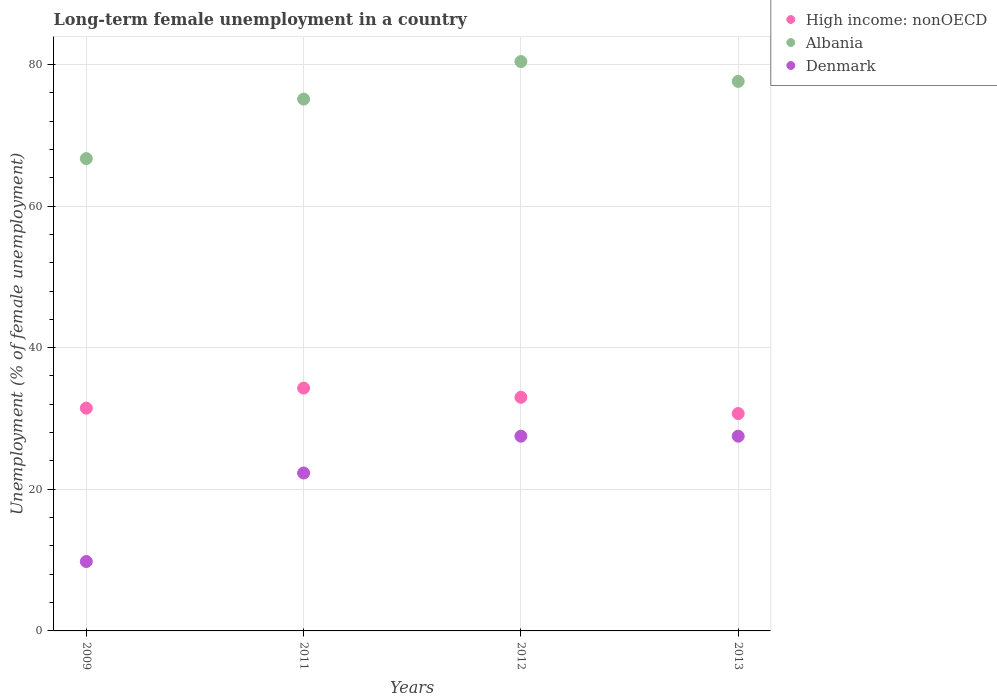What is the percentage of long-term unemployed female population in Albania in 2009?
Provide a short and direct response. 66.7. Across all years, what is the maximum percentage of long-term unemployed female population in High income: nonOECD?
Make the answer very short. 34.29. Across all years, what is the minimum percentage of long-term unemployed female population in Denmark?
Your answer should be very brief. 9.8. In which year was the percentage of long-term unemployed female population in High income: nonOECD minimum?
Your answer should be very brief. 2013. What is the total percentage of long-term unemployed female population in Denmark in the graph?
Keep it short and to the point. 87.1. What is the difference between the percentage of long-term unemployed female population in High income: nonOECD in 2011 and that in 2012?
Ensure brevity in your answer.  1.3. What is the difference between the percentage of long-term unemployed female population in High income: nonOECD in 2013 and the percentage of long-term unemployed female population in Denmark in 2009?
Your response must be concise. 20.9. What is the average percentage of long-term unemployed female population in Denmark per year?
Make the answer very short. 21.77. In the year 2011, what is the difference between the percentage of long-term unemployed female population in High income: nonOECD and percentage of long-term unemployed female population in Denmark?
Offer a very short reply. 11.99. In how many years, is the percentage of long-term unemployed female population in High income: nonOECD greater than 64 %?
Keep it short and to the point. 0. What is the ratio of the percentage of long-term unemployed female population in High income: nonOECD in 2009 to that in 2011?
Make the answer very short. 0.92. What is the difference between the highest and the lowest percentage of long-term unemployed female population in Denmark?
Your answer should be compact. 17.7. In how many years, is the percentage of long-term unemployed female population in Albania greater than the average percentage of long-term unemployed female population in Albania taken over all years?
Make the answer very short. 3. Is the sum of the percentage of long-term unemployed female population in Denmark in 2011 and 2013 greater than the maximum percentage of long-term unemployed female population in High income: nonOECD across all years?
Offer a very short reply. Yes. Does the percentage of long-term unemployed female population in Albania monotonically increase over the years?
Offer a terse response. No. Is the percentage of long-term unemployed female population in Denmark strictly greater than the percentage of long-term unemployed female population in Albania over the years?
Offer a terse response. No. How many years are there in the graph?
Your answer should be very brief. 4. Are the values on the major ticks of Y-axis written in scientific E-notation?
Give a very brief answer. No. Does the graph contain any zero values?
Provide a short and direct response. No. How many legend labels are there?
Offer a terse response. 3. How are the legend labels stacked?
Your answer should be compact. Vertical. What is the title of the graph?
Offer a terse response. Long-term female unemployment in a country. Does "St. Vincent and the Grenadines" appear as one of the legend labels in the graph?
Ensure brevity in your answer.  No. What is the label or title of the Y-axis?
Offer a very short reply. Unemployment (% of female unemployment). What is the Unemployment (% of female unemployment) of High income: nonOECD in 2009?
Ensure brevity in your answer.  31.45. What is the Unemployment (% of female unemployment) of Albania in 2009?
Provide a succinct answer. 66.7. What is the Unemployment (% of female unemployment) of Denmark in 2009?
Provide a short and direct response. 9.8. What is the Unemployment (% of female unemployment) in High income: nonOECD in 2011?
Offer a very short reply. 34.29. What is the Unemployment (% of female unemployment) in Albania in 2011?
Keep it short and to the point. 75.1. What is the Unemployment (% of female unemployment) of Denmark in 2011?
Your response must be concise. 22.3. What is the Unemployment (% of female unemployment) of High income: nonOECD in 2012?
Your response must be concise. 32.99. What is the Unemployment (% of female unemployment) in Albania in 2012?
Offer a very short reply. 80.4. What is the Unemployment (% of female unemployment) in High income: nonOECD in 2013?
Make the answer very short. 30.7. What is the Unemployment (% of female unemployment) in Albania in 2013?
Provide a succinct answer. 77.6. Across all years, what is the maximum Unemployment (% of female unemployment) in High income: nonOECD?
Make the answer very short. 34.29. Across all years, what is the maximum Unemployment (% of female unemployment) in Albania?
Keep it short and to the point. 80.4. Across all years, what is the maximum Unemployment (% of female unemployment) of Denmark?
Ensure brevity in your answer.  27.5. Across all years, what is the minimum Unemployment (% of female unemployment) of High income: nonOECD?
Ensure brevity in your answer.  30.7. Across all years, what is the minimum Unemployment (% of female unemployment) of Albania?
Provide a succinct answer. 66.7. Across all years, what is the minimum Unemployment (% of female unemployment) of Denmark?
Your answer should be compact. 9.8. What is the total Unemployment (% of female unemployment) of High income: nonOECD in the graph?
Provide a succinct answer. 129.43. What is the total Unemployment (% of female unemployment) of Albania in the graph?
Offer a very short reply. 299.8. What is the total Unemployment (% of female unemployment) in Denmark in the graph?
Provide a short and direct response. 87.1. What is the difference between the Unemployment (% of female unemployment) of High income: nonOECD in 2009 and that in 2011?
Provide a short and direct response. -2.84. What is the difference between the Unemployment (% of female unemployment) in Denmark in 2009 and that in 2011?
Provide a succinct answer. -12.5. What is the difference between the Unemployment (% of female unemployment) of High income: nonOECD in 2009 and that in 2012?
Offer a terse response. -1.54. What is the difference between the Unemployment (% of female unemployment) of Albania in 2009 and that in 2012?
Offer a very short reply. -13.7. What is the difference between the Unemployment (% of female unemployment) in Denmark in 2009 and that in 2012?
Make the answer very short. -17.7. What is the difference between the Unemployment (% of female unemployment) in High income: nonOECD in 2009 and that in 2013?
Offer a terse response. 0.76. What is the difference between the Unemployment (% of female unemployment) of Albania in 2009 and that in 2013?
Your response must be concise. -10.9. What is the difference between the Unemployment (% of female unemployment) in Denmark in 2009 and that in 2013?
Give a very brief answer. -17.7. What is the difference between the Unemployment (% of female unemployment) in High income: nonOECD in 2011 and that in 2012?
Give a very brief answer. 1.3. What is the difference between the Unemployment (% of female unemployment) in Albania in 2011 and that in 2012?
Provide a succinct answer. -5.3. What is the difference between the Unemployment (% of female unemployment) of High income: nonOECD in 2011 and that in 2013?
Keep it short and to the point. 3.59. What is the difference between the Unemployment (% of female unemployment) of High income: nonOECD in 2012 and that in 2013?
Provide a short and direct response. 2.29. What is the difference between the Unemployment (% of female unemployment) in High income: nonOECD in 2009 and the Unemployment (% of female unemployment) in Albania in 2011?
Your answer should be very brief. -43.65. What is the difference between the Unemployment (% of female unemployment) of High income: nonOECD in 2009 and the Unemployment (% of female unemployment) of Denmark in 2011?
Offer a terse response. 9.15. What is the difference between the Unemployment (% of female unemployment) of Albania in 2009 and the Unemployment (% of female unemployment) of Denmark in 2011?
Give a very brief answer. 44.4. What is the difference between the Unemployment (% of female unemployment) in High income: nonOECD in 2009 and the Unemployment (% of female unemployment) in Albania in 2012?
Offer a very short reply. -48.95. What is the difference between the Unemployment (% of female unemployment) in High income: nonOECD in 2009 and the Unemployment (% of female unemployment) in Denmark in 2012?
Your answer should be compact. 3.95. What is the difference between the Unemployment (% of female unemployment) of Albania in 2009 and the Unemployment (% of female unemployment) of Denmark in 2012?
Make the answer very short. 39.2. What is the difference between the Unemployment (% of female unemployment) in High income: nonOECD in 2009 and the Unemployment (% of female unemployment) in Albania in 2013?
Ensure brevity in your answer.  -46.15. What is the difference between the Unemployment (% of female unemployment) of High income: nonOECD in 2009 and the Unemployment (% of female unemployment) of Denmark in 2013?
Offer a terse response. 3.95. What is the difference between the Unemployment (% of female unemployment) in Albania in 2009 and the Unemployment (% of female unemployment) in Denmark in 2013?
Provide a short and direct response. 39.2. What is the difference between the Unemployment (% of female unemployment) of High income: nonOECD in 2011 and the Unemployment (% of female unemployment) of Albania in 2012?
Offer a very short reply. -46.11. What is the difference between the Unemployment (% of female unemployment) in High income: nonOECD in 2011 and the Unemployment (% of female unemployment) in Denmark in 2012?
Ensure brevity in your answer.  6.79. What is the difference between the Unemployment (% of female unemployment) of Albania in 2011 and the Unemployment (% of female unemployment) of Denmark in 2012?
Your answer should be very brief. 47.6. What is the difference between the Unemployment (% of female unemployment) of High income: nonOECD in 2011 and the Unemployment (% of female unemployment) of Albania in 2013?
Your answer should be very brief. -43.31. What is the difference between the Unemployment (% of female unemployment) in High income: nonOECD in 2011 and the Unemployment (% of female unemployment) in Denmark in 2013?
Give a very brief answer. 6.79. What is the difference between the Unemployment (% of female unemployment) in Albania in 2011 and the Unemployment (% of female unemployment) in Denmark in 2013?
Make the answer very short. 47.6. What is the difference between the Unemployment (% of female unemployment) of High income: nonOECD in 2012 and the Unemployment (% of female unemployment) of Albania in 2013?
Keep it short and to the point. -44.61. What is the difference between the Unemployment (% of female unemployment) in High income: nonOECD in 2012 and the Unemployment (% of female unemployment) in Denmark in 2013?
Provide a short and direct response. 5.49. What is the difference between the Unemployment (% of female unemployment) of Albania in 2012 and the Unemployment (% of female unemployment) of Denmark in 2013?
Give a very brief answer. 52.9. What is the average Unemployment (% of female unemployment) in High income: nonOECD per year?
Offer a very short reply. 32.36. What is the average Unemployment (% of female unemployment) of Albania per year?
Your response must be concise. 74.95. What is the average Unemployment (% of female unemployment) in Denmark per year?
Your response must be concise. 21.77. In the year 2009, what is the difference between the Unemployment (% of female unemployment) in High income: nonOECD and Unemployment (% of female unemployment) in Albania?
Ensure brevity in your answer.  -35.25. In the year 2009, what is the difference between the Unemployment (% of female unemployment) of High income: nonOECD and Unemployment (% of female unemployment) of Denmark?
Your response must be concise. 21.65. In the year 2009, what is the difference between the Unemployment (% of female unemployment) in Albania and Unemployment (% of female unemployment) in Denmark?
Provide a succinct answer. 56.9. In the year 2011, what is the difference between the Unemployment (% of female unemployment) of High income: nonOECD and Unemployment (% of female unemployment) of Albania?
Ensure brevity in your answer.  -40.81. In the year 2011, what is the difference between the Unemployment (% of female unemployment) of High income: nonOECD and Unemployment (% of female unemployment) of Denmark?
Your answer should be compact. 11.99. In the year 2011, what is the difference between the Unemployment (% of female unemployment) of Albania and Unemployment (% of female unemployment) of Denmark?
Ensure brevity in your answer.  52.8. In the year 2012, what is the difference between the Unemployment (% of female unemployment) in High income: nonOECD and Unemployment (% of female unemployment) in Albania?
Keep it short and to the point. -47.41. In the year 2012, what is the difference between the Unemployment (% of female unemployment) of High income: nonOECD and Unemployment (% of female unemployment) of Denmark?
Offer a very short reply. 5.49. In the year 2012, what is the difference between the Unemployment (% of female unemployment) in Albania and Unemployment (% of female unemployment) in Denmark?
Your answer should be very brief. 52.9. In the year 2013, what is the difference between the Unemployment (% of female unemployment) in High income: nonOECD and Unemployment (% of female unemployment) in Albania?
Make the answer very short. -46.9. In the year 2013, what is the difference between the Unemployment (% of female unemployment) of High income: nonOECD and Unemployment (% of female unemployment) of Denmark?
Your answer should be very brief. 3.2. In the year 2013, what is the difference between the Unemployment (% of female unemployment) in Albania and Unemployment (% of female unemployment) in Denmark?
Keep it short and to the point. 50.1. What is the ratio of the Unemployment (% of female unemployment) in High income: nonOECD in 2009 to that in 2011?
Provide a short and direct response. 0.92. What is the ratio of the Unemployment (% of female unemployment) in Albania in 2009 to that in 2011?
Offer a very short reply. 0.89. What is the ratio of the Unemployment (% of female unemployment) in Denmark in 2009 to that in 2011?
Provide a short and direct response. 0.44. What is the ratio of the Unemployment (% of female unemployment) in High income: nonOECD in 2009 to that in 2012?
Give a very brief answer. 0.95. What is the ratio of the Unemployment (% of female unemployment) in Albania in 2009 to that in 2012?
Provide a succinct answer. 0.83. What is the ratio of the Unemployment (% of female unemployment) in Denmark in 2009 to that in 2012?
Your answer should be very brief. 0.36. What is the ratio of the Unemployment (% of female unemployment) of High income: nonOECD in 2009 to that in 2013?
Give a very brief answer. 1.02. What is the ratio of the Unemployment (% of female unemployment) of Albania in 2009 to that in 2013?
Provide a short and direct response. 0.86. What is the ratio of the Unemployment (% of female unemployment) of Denmark in 2009 to that in 2013?
Offer a very short reply. 0.36. What is the ratio of the Unemployment (% of female unemployment) in High income: nonOECD in 2011 to that in 2012?
Provide a succinct answer. 1.04. What is the ratio of the Unemployment (% of female unemployment) of Albania in 2011 to that in 2012?
Keep it short and to the point. 0.93. What is the ratio of the Unemployment (% of female unemployment) in Denmark in 2011 to that in 2012?
Keep it short and to the point. 0.81. What is the ratio of the Unemployment (% of female unemployment) of High income: nonOECD in 2011 to that in 2013?
Provide a succinct answer. 1.12. What is the ratio of the Unemployment (% of female unemployment) in Albania in 2011 to that in 2013?
Make the answer very short. 0.97. What is the ratio of the Unemployment (% of female unemployment) in Denmark in 2011 to that in 2013?
Make the answer very short. 0.81. What is the ratio of the Unemployment (% of female unemployment) in High income: nonOECD in 2012 to that in 2013?
Provide a succinct answer. 1.07. What is the ratio of the Unemployment (% of female unemployment) of Albania in 2012 to that in 2013?
Ensure brevity in your answer.  1.04. What is the difference between the highest and the second highest Unemployment (% of female unemployment) of High income: nonOECD?
Offer a very short reply. 1.3. What is the difference between the highest and the second highest Unemployment (% of female unemployment) of Denmark?
Provide a short and direct response. 0. What is the difference between the highest and the lowest Unemployment (% of female unemployment) in High income: nonOECD?
Ensure brevity in your answer.  3.59. What is the difference between the highest and the lowest Unemployment (% of female unemployment) in Denmark?
Give a very brief answer. 17.7. 